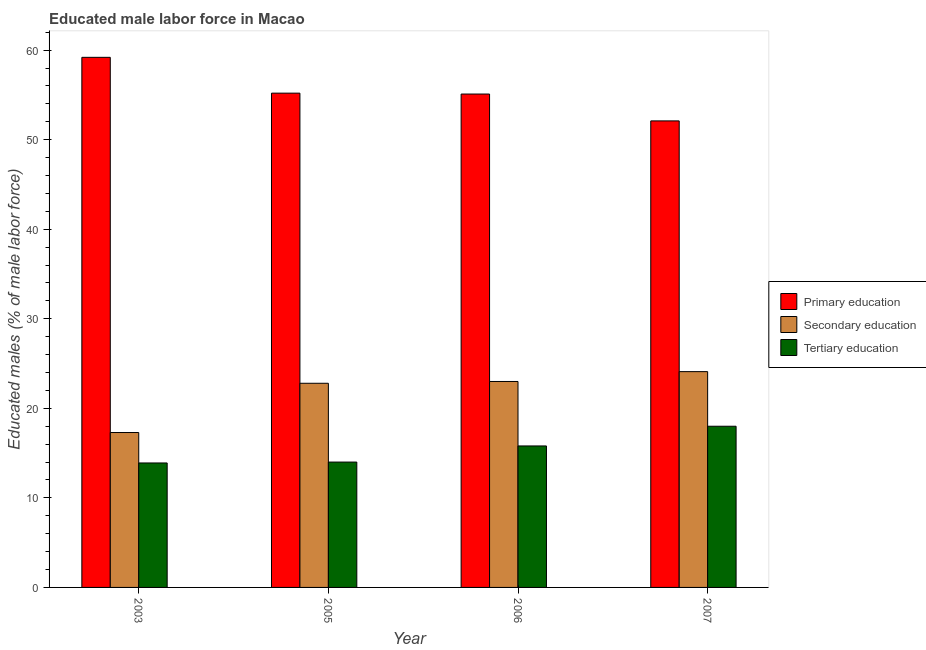How many different coloured bars are there?
Your answer should be compact. 3. Are the number of bars on each tick of the X-axis equal?
Give a very brief answer. Yes. How many bars are there on the 3rd tick from the left?
Provide a succinct answer. 3. How many bars are there on the 4th tick from the right?
Your answer should be very brief. 3. Across all years, what is the maximum percentage of male labor force who received secondary education?
Make the answer very short. 24.1. Across all years, what is the minimum percentage of male labor force who received secondary education?
Your response must be concise. 17.3. In which year was the percentage of male labor force who received tertiary education maximum?
Offer a terse response. 2007. In which year was the percentage of male labor force who received secondary education minimum?
Provide a succinct answer. 2003. What is the total percentage of male labor force who received primary education in the graph?
Provide a short and direct response. 221.6. What is the difference between the percentage of male labor force who received secondary education in 2006 and that in 2007?
Your answer should be compact. -1.1. What is the difference between the percentage of male labor force who received tertiary education in 2007 and the percentage of male labor force who received primary education in 2005?
Provide a short and direct response. 4. What is the average percentage of male labor force who received primary education per year?
Give a very brief answer. 55.4. In the year 2005, what is the difference between the percentage of male labor force who received secondary education and percentage of male labor force who received tertiary education?
Ensure brevity in your answer.  0. What is the ratio of the percentage of male labor force who received secondary education in 2003 to that in 2006?
Give a very brief answer. 0.75. Is the percentage of male labor force who received secondary education in 2003 less than that in 2006?
Your answer should be compact. Yes. Is the difference between the percentage of male labor force who received secondary education in 2005 and 2007 greater than the difference between the percentage of male labor force who received tertiary education in 2005 and 2007?
Keep it short and to the point. No. What is the difference between the highest and the second highest percentage of male labor force who received secondary education?
Offer a terse response. 1.1. What is the difference between the highest and the lowest percentage of male labor force who received secondary education?
Ensure brevity in your answer.  6.8. Is the sum of the percentage of male labor force who received secondary education in 2003 and 2005 greater than the maximum percentage of male labor force who received tertiary education across all years?
Your answer should be very brief. Yes. What does the 2nd bar from the left in 2003 represents?
Provide a short and direct response. Secondary education. What does the 3rd bar from the right in 2006 represents?
Your answer should be very brief. Primary education. Are all the bars in the graph horizontal?
Offer a very short reply. No. How many years are there in the graph?
Provide a succinct answer. 4. Are the values on the major ticks of Y-axis written in scientific E-notation?
Ensure brevity in your answer.  No. Does the graph contain grids?
Offer a terse response. No. Where does the legend appear in the graph?
Give a very brief answer. Center right. What is the title of the graph?
Your answer should be compact. Educated male labor force in Macao. Does "Social Insurance" appear as one of the legend labels in the graph?
Keep it short and to the point. No. What is the label or title of the X-axis?
Ensure brevity in your answer.  Year. What is the label or title of the Y-axis?
Ensure brevity in your answer.  Educated males (% of male labor force). What is the Educated males (% of male labor force) in Primary education in 2003?
Offer a terse response. 59.2. What is the Educated males (% of male labor force) in Secondary education in 2003?
Keep it short and to the point. 17.3. What is the Educated males (% of male labor force) of Tertiary education in 2003?
Your response must be concise. 13.9. What is the Educated males (% of male labor force) in Primary education in 2005?
Your answer should be compact. 55.2. What is the Educated males (% of male labor force) in Secondary education in 2005?
Your answer should be very brief. 22.8. What is the Educated males (% of male labor force) in Primary education in 2006?
Offer a very short reply. 55.1. What is the Educated males (% of male labor force) in Secondary education in 2006?
Provide a succinct answer. 23. What is the Educated males (% of male labor force) of Tertiary education in 2006?
Your response must be concise. 15.8. What is the Educated males (% of male labor force) in Primary education in 2007?
Offer a very short reply. 52.1. What is the Educated males (% of male labor force) in Secondary education in 2007?
Ensure brevity in your answer.  24.1. What is the Educated males (% of male labor force) in Tertiary education in 2007?
Your answer should be compact. 18. Across all years, what is the maximum Educated males (% of male labor force) of Primary education?
Offer a terse response. 59.2. Across all years, what is the maximum Educated males (% of male labor force) of Secondary education?
Provide a succinct answer. 24.1. Across all years, what is the maximum Educated males (% of male labor force) of Tertiary education?
Keep it short and to the point. 18. Across all years, what is the minimum Educated males (% of male labor force) in Primary education?
Offer a terse response. 52.1. Across all years, what is the minimum Educated males (% of male labor force) in Secondary education?
Offer a terse response. 17.3. Across all years, what is the minimum Educated males (% of male labor force) of Tertiary education?
Provide a succinct answer. 13.9. What is the total Educated males (% of male labor force) in Primary education in the graph?
Provide a succinct answer. 221.6. What is the total Educated males (% of male labor force) in Secondary education in the graph?
Offer a very short reply. 87.2. What is the total Educated males (% of male labor force) of Tertiary education in the graph?
Keep it short and to the point. 61.7. What is the difference between the Educated males (% of male labor force) in Secondary education in 2003 and that in 2005?
Make the answer very short. -5.5. What is the difference between the Educated males (% of male labor force) in Tertiary education in 2003 and that in 2005?
Give a very brief answer. -0.1. What is the difference between the Educated males (% of male labor force) in Primary education in 2003 and that in 2006?
Offer a terse response. 4.1. What is the difference between the Educated males (% of male labor force) of Secondary education in 2003 and that in 2006?
Offer a terse response. -5.7. What is the difference between the Educated males (% of male labor force) in Tertiary education in 2003 and that in 2007?
Provide a short and direct response. -4.1. What is the difference between the Educated males (% of male labor force) of Primary education in 2005 and that in 2006?
Give a very brief answer. 0.1. What is the difference between the Educated males (% of male labor force) in Primary education in 2005 and that in 2007?
Give a very brief answer. 3.1. What is the difference between the Educated males (% of male labor force) of Tertiary education in 2005 and that in 2007?
Offer a very short reply. -4. What is the difference between the Educated males (% of male labor force) in Primary education in 2006 and that in 2007?
Make the answer very short. 3. What is the difference between the Educated males (% of male labor force) of Secondary education in 2006 and that in 2007?
Make the answer very short. -1.1. What is the difference between the Educated males (% of male labor force) in Tertiary education in 2006 and that in 2007?
Your answer should be very brief. -2.2. What is the difference between the Educated males (% of male labor force) in Primary education in 2003 and the Educated males (% of male labor force) in Secondary education in 2005?
Give a very brief answer. 36.4. What is the difference between the Educated males (% of male labor force) in Primary education in 2003 and the Educated males (% of male labor force) in Tertiary education in 2005?
Offer a terse response. 45.2. What is the difference between the Educated males (% of male labor force) of Primary education in 2003 and the Educated males (% of male labor force) of Secondary education in 2006?
Ensure brevity in your answer.  36.2. What is the difference between the Educated males (% of male labor force) in Primary education in 2003 and the Educated males (% of male labor force) in Tertiary education in 2006?
Offer a terse response. 43.4. What is the difference between the Educated males (% of male labor force) in Primary education in 2003 and the Educated males (% of male labor force) in Secondary education in 2007?
Your response must be concise. 35.1. What is the difference between the Educated males (% of male labor force) of Primary education in 2003 and the Educated males (% of male labor force) of Tertiary education in 2007?
Provide a succinct answer. 41.2. What is the difference between the Educated males (% of male labor force) in Secondary education in 2003 and the Educated males (% of male labor force) in Tertiary education in 2007?
Provide a short and direct response. -0.7. What is the difference between the Educated males (% of male labor force) of Primary education in 2005 and the Educated males (% of male labor force) of Secondary education in 2006?
Your answer should be compact. 32.2. What is the difference between the Educated males (% of male labor force) of Primary education in 2005 and the Educated males (% of male labor force) of Tertiary education in 2006?
Provide a succinct answer. 39.4. What is the difference between the Educated males (% of male labor force) of Primary education in 2005 and the Educated males (% of male labor force) of Secondary education in 2007?
Keep it short and to the point. 31.1. What is the difference between the Educated males (% of male labor force) in Primary education in 2005 and the Educated males (% of male labor force) in Tertiary education in 2007?
Give a very brief answer. 37.2. What is the difference between the Educated males (% of male labor force) in Secondary education in 2005 and the Educated males (% of male labor force) in Tertiary education in 2007?
Make the answer very short. 4.8. What is the difference between the Educated males (% of male labor force) of Primary education in 2006 and the Educated males (% of male labor force) of Secondary education in 2007?
Keep it short and to the point. 31. What is the difference between the Educated males (% of male labor force) in Primary education in 2006 and the Educated males (% of male labor force) in Tertiary education in 2007?
Give a very brief answer. 37.1. What is the average Educated males (% of male labor force) of Primary education per year?
Your answer should be very brief. 55.4. What is the average Educated males (% of male labor force) of Secondary education per year?
Offer a very short reply. 21.8. What is the average Educated males (% of male labor force) of Tertiary education per year?
Make the answer very short. 15.43. In the year 2003, what is the difference between the Educated males (% of male labor force) of Primary education and Educated males (% of male labor force) of Secondary education?
Provide a short and direct response. 41.9. In the year 2003, what is the difference between the Educated males (% of male labor force) of Primary education and Educated males (% of male labor force) of Tertiary education?
Keep it short and to the point. 45.3. In the year 2005, what is the difference between the Educated males (% of male labor force) of Primary education and Educated males (% of male labor force) of Secondary education?
Your response must be concise. 32.4. In the year 2005, what is the difference between the Educated males (% of male labor force) in Primary education and Educated males (% of male labor force) in Tertiary education?
Offer a very short reply. 41.2. In the year 2006, what is the difference between the Educated males (% of male labor force) in Primary education and Educated males (% of male labor force) in Secondary education?
Keep it short and to the point. 32.1. In the year 2006, what is the difference between the Educated males (% of male labor force) of Primary education and Educated males (% of male labor force) of Tertiary education?
Ensure brevity in your answer.  39.3. In the year 2007, what is the difference between the Educated males (% of male labor force) of Primary education and Educated males (% of male labor force) of Secondary education?
Provide a short and direct response. 28. In the year 2007, what is the difference between the Educated males (% of male labor force) in Primary education and Educated males (% of male labor force) in Tertiary education?
Offer a terse response. 34.1. What is the ratio of the Educated males (% of male labor force) of Primary education in 2003 to that in 2005?
Ensure brevity in your answer.  1.07. What is the ratio of the Educated males (% of male labor force) of Secondary education in 2003 to that in 2005?
Make the answer very short. 0.76. What is the ratio of the Educated males (% of male labor force) in Tertiary education in 2003 to that in 2005?
Offer a very short reply. 0.99. What is the ratio of the Educated males (% of male labor force) of Primary education in 2003 to that in 2006?
Keep it short and to the point. 1.07. What is the ratio of the Educated males (% of male labor force) of Secondary education in 2003 to that in 2006?
Your response must be concise. 0.75. What is the ratio of the Educated males (% of male labor force) of Tertiary education in 2003 to that in 2006?
Make the answer very short. 0.88. What is the ratio of the Educated males (% of male labor force) of Primary education in 2003 to that in 2007?
Provide a short and direct response. 1.14. What is the ratio of the Educated males (% of male labor force) in Secondary education in 2003 to that in 2007?
Give a very brief answer. 0.72. What is the ratio of the Educated males (% of male labor force) of Tertiary education in 2003 to that in 2007?
Give a very brief answer. 0.77. What is the ratio of the Educated males (% of male labor force) in Secondary education in 2005 to that in 2006?
Provide a succinct answer. 0.99. What is the ratio of the Educated males (% of male labor force) of Tertiary education in 2005 to that in 2006?
Offer a very short reply. 0.89. What is the ratio of the Educated males (% of male labor force) of Primary education in 2005 to that in 2007?
Offer a terse response. 1.06. What is the ratio of the Educated males (% of male labor force) of Secondary education in 2005 to that in 2007?
Your answer should be very brief. 0.95. What is the ratio of the Educated males (% of male labor force) of Tertiary education in 2005 to that in 2007?
Offer a very short reply. 0.78. What is the ratio of the Educated males (% of male labor force) of Primary education in 2006 to that in 2007?
Ensure brevity in your answer.  1.06. What is the ratio of the Educated males (% of male labor force) of Secondary education in 2006 to that in 2007?
Give a very brief answer. 0.95. What is the ratio of the Educated males (% of male labor force) in Tertiary education in 2006 to that in 2007?
Offer a very short reply. 0.88. What is the difference between the highest and the lowest Educated males (% of male labor force) of Primary education?
Your answer should be compact. 7.1. What is the difference between the highest and the lowest Educated males (% of male labor force) of Secondary education?
Offer a terse response. 6.8. 